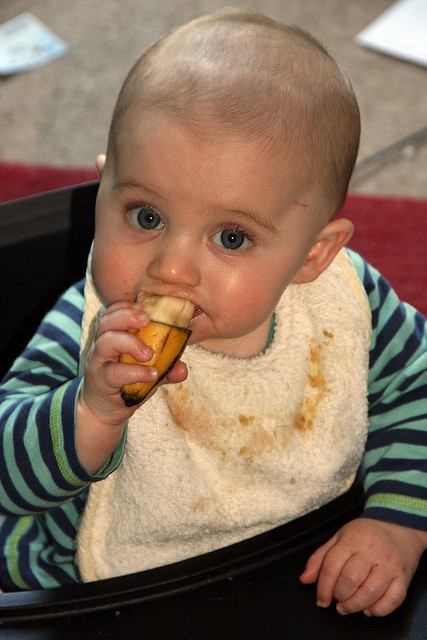Describe the objects in this image and their specific colors. I can see people in gray, tan, and black tones and banana in gray, brown, tan, salmon, and orange tones in this image. 